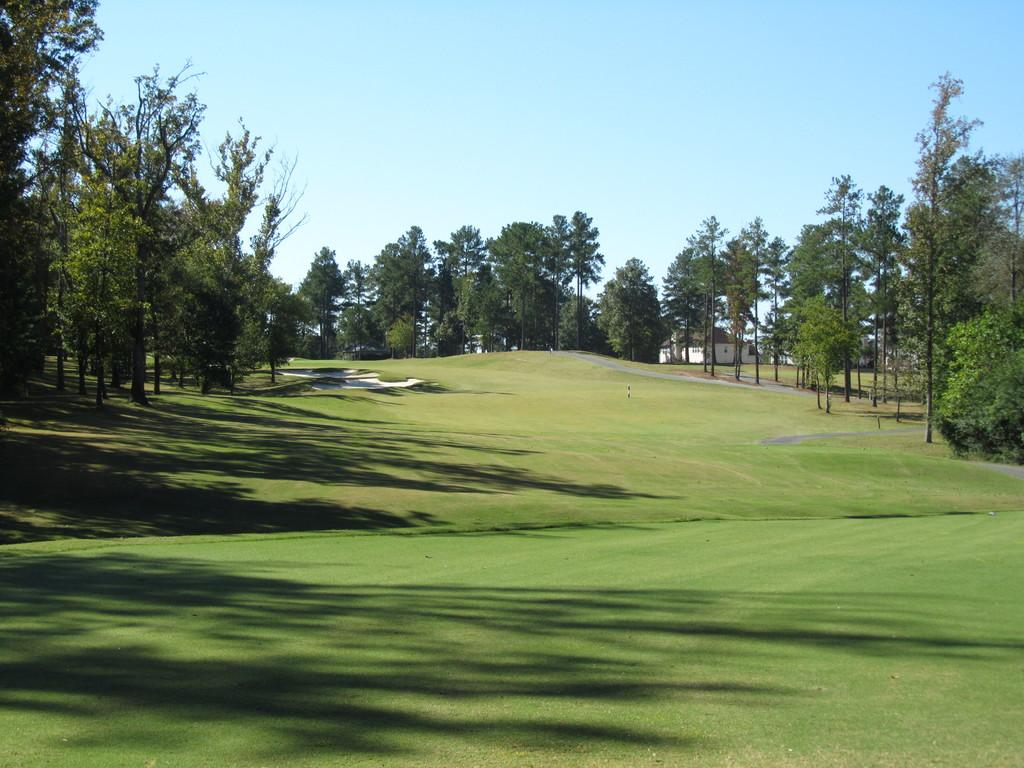What type of vegetation can be seen in the image? There are trees in the image. What type of structure is present in the image? There is a shed in the image. What is visible in the background of the image? The sky is visible in the background of the image. What type of waves can be seen in the image? There are no waves present in the image; it features trees, a shed, and the sky. Is there a ship visible in the image? No, there is no ship present in the image. 